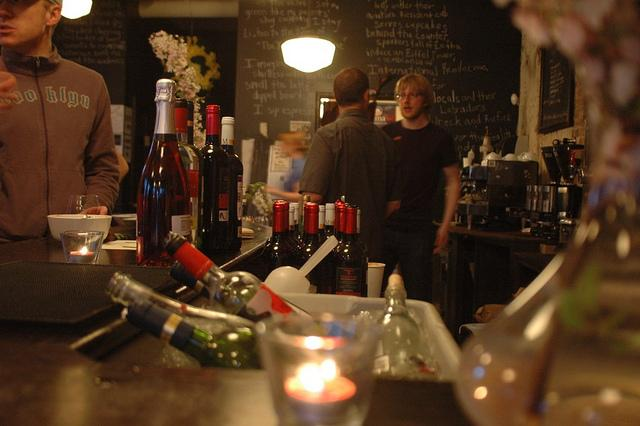Where are these people located? Please explain your reasoning. restaurant. All the bottles are a clear indication that this is not a classroom or a theatre. the only way there would be bottles in an office would be at a party and it's obvious just by looking that this is not an office. 